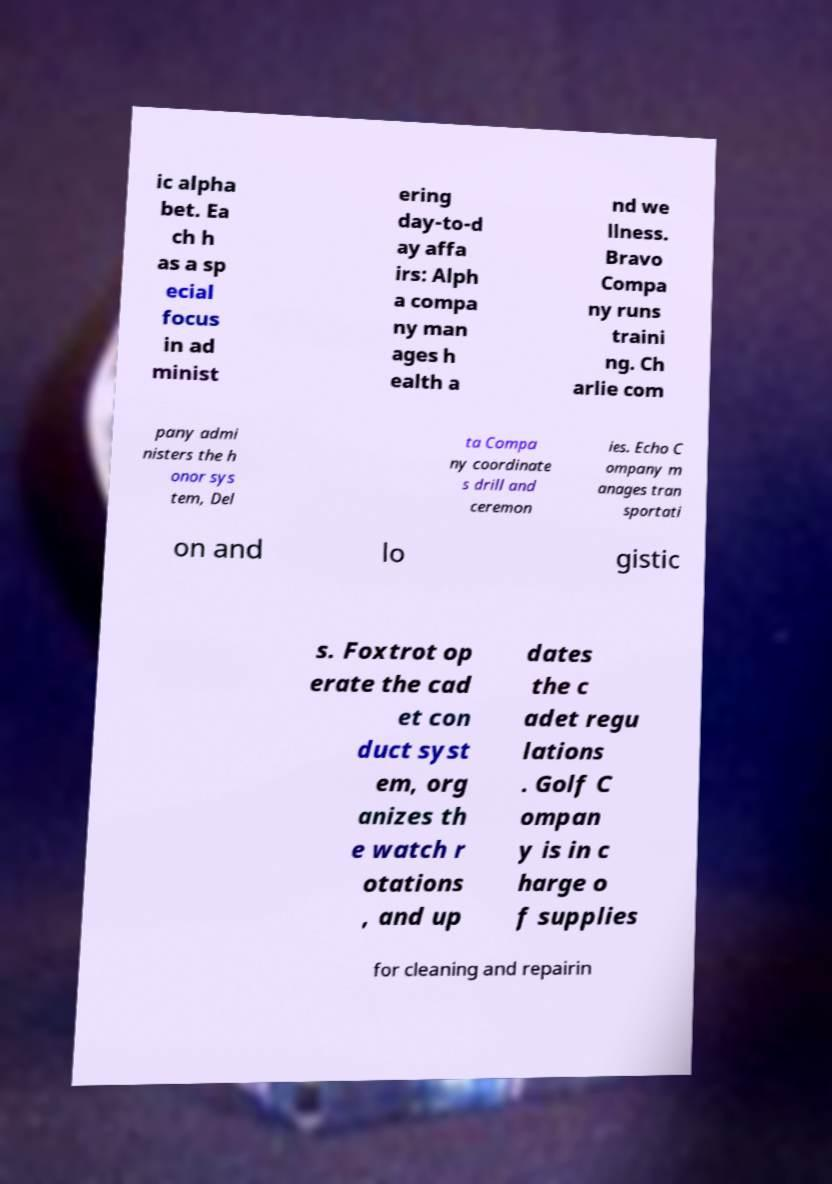Can you accurately transcribe the text from the provided image for me? ic alpha bet. Ea ch h as a sp ecial focus in ad minist ering day-to-d ay affa irs: Alph a compa ny man ages h ealth a nd we llness. Bravo Compa ny runs traini ng. Ch arlie com pany admi nisters the h onor sys tem, Del ta Compa ny coordinate s drill and ceremon ies. Echo C ompany m anages tran sportati on and lo gistic s. Foxtrot op erate the cad et con duct syst em, org anizes th e watch r otations , and up dates the c adet regu lations . Golf C ompan y is in c harge o f supplies for cleaning and repairin 